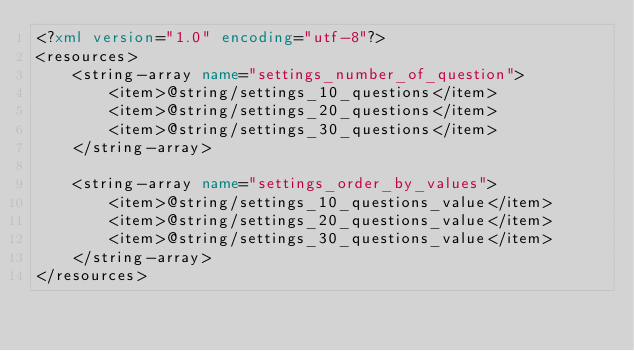Convert code to text. <code><loc_0><loc_0><loc_500><loc_500><_XML_><?xml version="1.0" encoding="utf-8"?>
<resources>
    <string-array name="settings_number_of_question">
        <item>@string/settings_10_questions</item>
        <item>@string/settings_20_questions</item>
        <item>@string/settings_30_questions</item>
    </string-array>

    <string-array name="settings_order_by_values">
        <item>@string/settings_10_questions_value</item>
        <item>@string/settings_20_questions_value</item>
        <item>@string/settings_30_questions_value</item>
    </string-array>
</resources></code> 